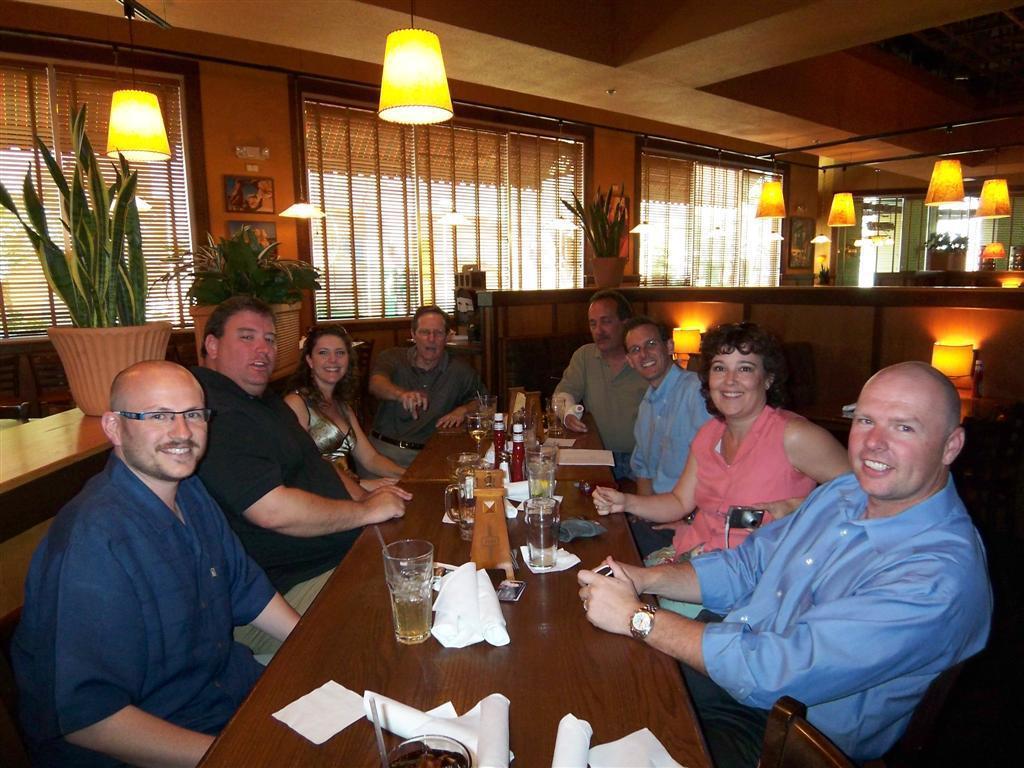Can you describe this image briefly? This image is taken in a restaurant. There are eight people in this image. In the middle of the image there is table which contains a glass, tissues, bottle, paper, a bowl with food. In the right side of the image a man is sitting in a chair, beside him a woman is sitting and beside woman there are two men sitting on a chair. There are few lumps in right side of the image. In the left side of the image there is a house plant with a pot and a man sitting on a chair with a smiling face. 